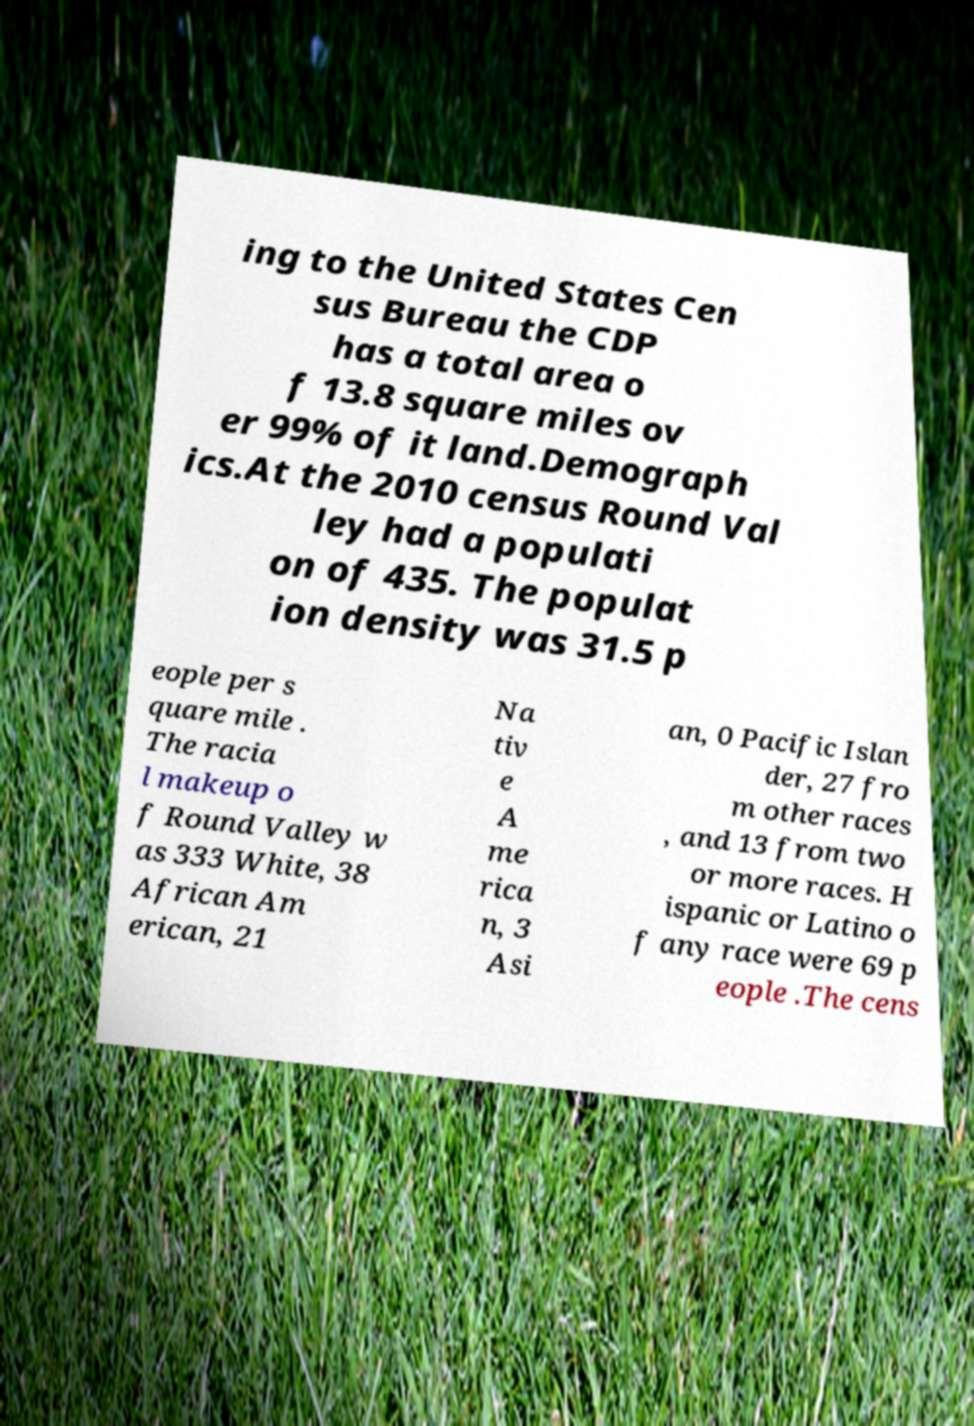What messages or text are displayed in this image? I need them in a readable, typed format. ing to the United States Cen sus Bureau the CDP has a total area o f 13.8 square miles ov er 99% of it land.Demograph ics.At the 2010 census Round Val ley had a populati on of 435. The populat ion density was 31.5 p eople per s quare mile . The racia l makeup o f Round Valley w as 333 White, 38 African Am erican, 21 Na tiv e A me rica n, 3 Asi an, 0 Pacific Islan der, 27 fro m other races , and 13 from two or more races. H ispanic or Latino o f any race were 69 p eople .The cens 